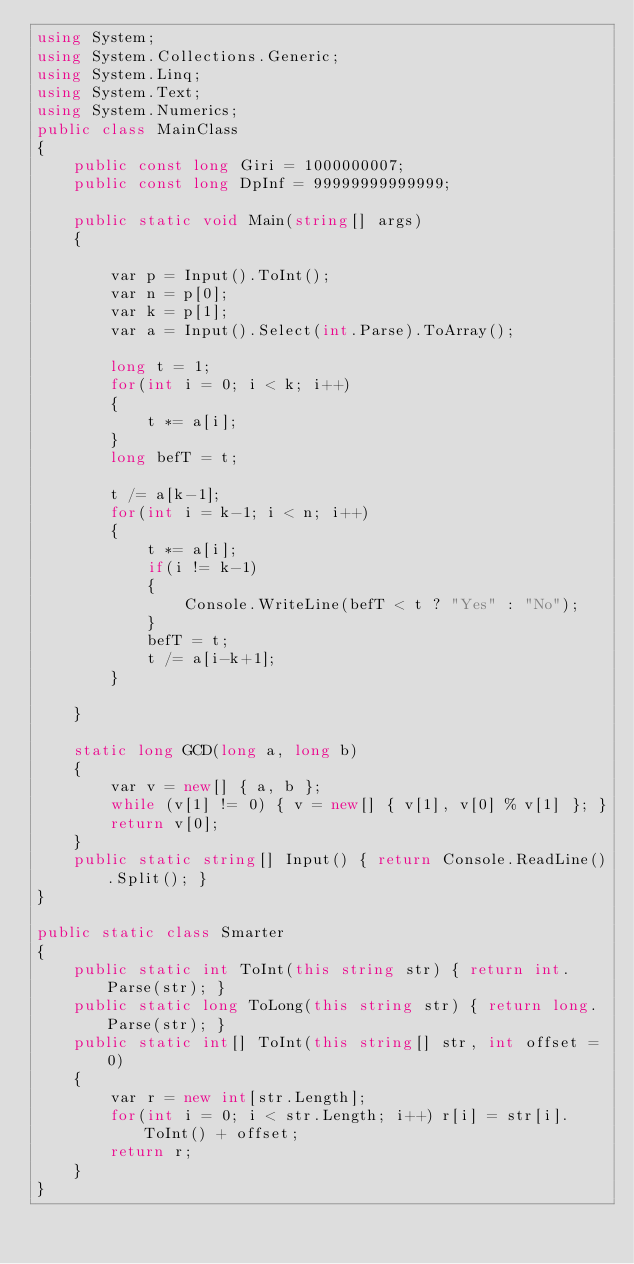Convert code to text. <code><loc_0><loc_0><loc_500><loc_500><_C#_>using System;
using System.Collections.Generic;
using System.Linq;
using System.Text;
using System.Numerics;
public class MainClass
{
	public const long Giri = 1000000007;
	public const long DpInf = 99999999999999;
	
	public static void Main(string[] args)
	{
	
		var p = Input().ToInt();
		var n = p[0];
		var k = p[1];
		var a = Input().Select(int.Parse).ToArray();
		
		long t = 1;
		for(int i = 0; i < k; i++)
		{
			t *= a[i];
		}
		long befT = t;
		
		t /= a[k-1];
		for(int i = k-1; i < n; i++)
		{
			t *= a[i];
			if(i != k-1)
			{
				Console.WriteLine(befT < t ? "Yes" : "No");
			}
			befT = t;
			t /= a[i-k+1];
		}
		
	}
	
	static long GCD(long a, long b)
	{
		var v = new[] { a, b };
		while (v[1] != 0) { v = new[] { v[1], v[0] % v[1] }; }
		return v[0];
	}
	public static string[] Input() { return Console.ReadLine().Split(); }
}

public static class Smarter
{
	public static int ToInt(this string str) { return int.Parse(str); }
	public static long ToLong(this string str) { return long.Parse(str); }
	public static int[] ToInt(this string[] str, int offset = 0)
	{
		var r = new int[str.Length];
		for(int i = 0; i < str.Length; i++) r[i] = str[i].ToInt() + offset;
		return r;
	}
}</code> 